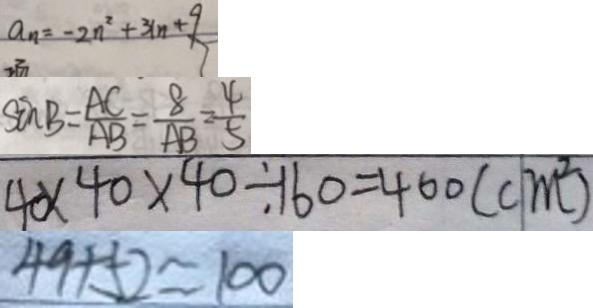<formula> <loc_0><loc_0><loc_500><loc_500>a _ { n } = - 2 n ^ { 2 } + 3 ( n + 9 
 \sin B = \frac { A C } { A B } = \frac { 8 } { A B } = \frac { 4 } { 5 } 
 4 \times 4 0 \times 4 0 \div 1 6 0 = 4 0 0 ( c m ^ { 2 } ) 
 4 9 + 5 2 \approx 1 0 0</formula> 